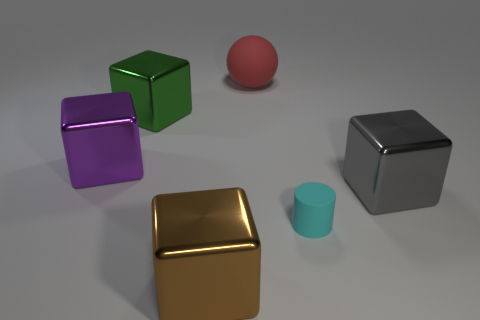Is there anything else that has the same size as the cyan object?
Your answer should be compact. No. There is a metallic thing behind the purple metallic object; what is its color?
Make the answer very short. Green. There is a brown block on the left side of the big cube to the right of the cyan cylinder; what number of large green blocks are to the left of it?
Your answer should be very brief. 1. What size is the cyan rubber cylinder?
Your answer should be compact. Small. There is a green thing that is the same size as the purple metallic thing; what is it made of?
Your response must be concise. Metal. There is a green metal thing; how many cyan matte things are to the left of it?
Provide a short and direct response. 0. Are the object behind the green shiny block and the cyan cylinder in front of the big green metallic cube made of the same material?
Your answer should be very brief. Yes. There is a metal thing that is behind the shiny cube left of the cube behind the big purple metal cube; what shape is it?
Give a very brief answer. Cube. The brown object has what shape?
Offer a very short reply. Cube. The gray shiny thing that is the same size as the purple metal block is what shape?
Provide a short and direct response. Cube. 